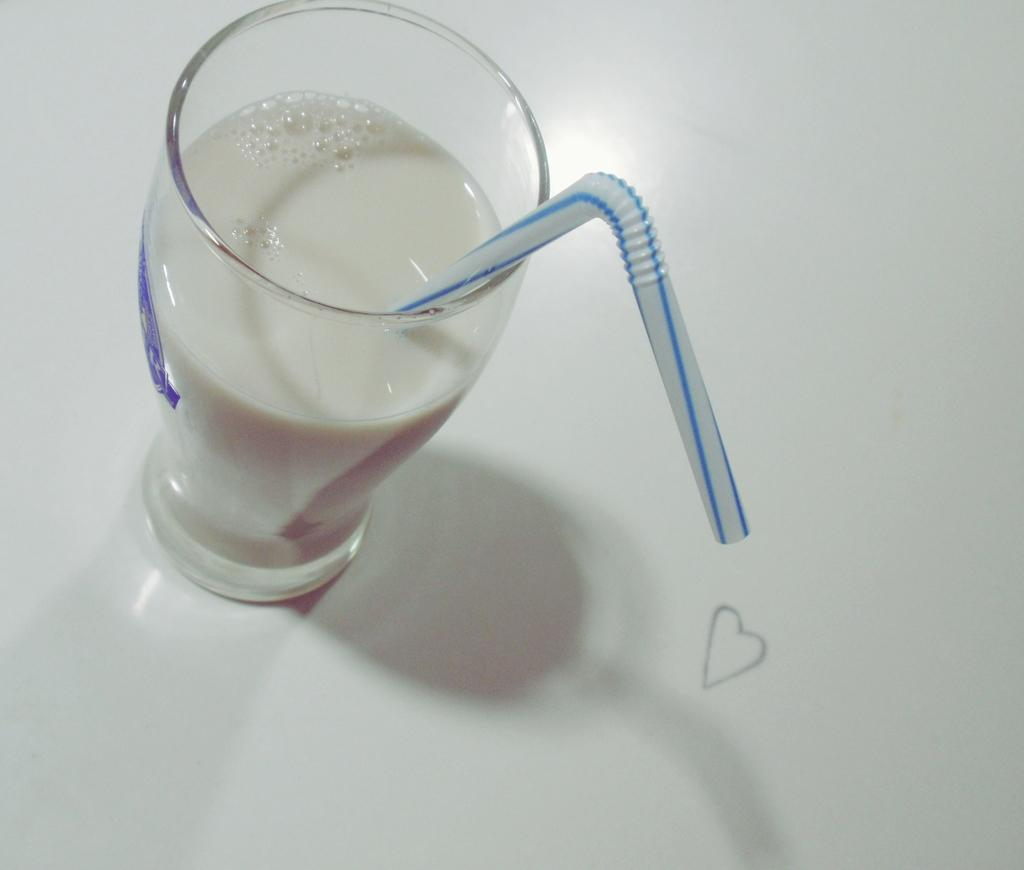What object is present in the image that can hold a liquid? There is a glass in the image that can hold a liquid. What is the color of the liquid inside the glass? The liquid in the glass is white in color. What is used to drink the liquid in the glass? There is a white-colored straw in the glass. What is the color of the surface on which the glass is placed? The glass is placed on a white-colored surface. Where is the vase located in the image? There is no vase present in the image. What type of tool is the farmer using in the image? There is no farmer or tool present in the image. 